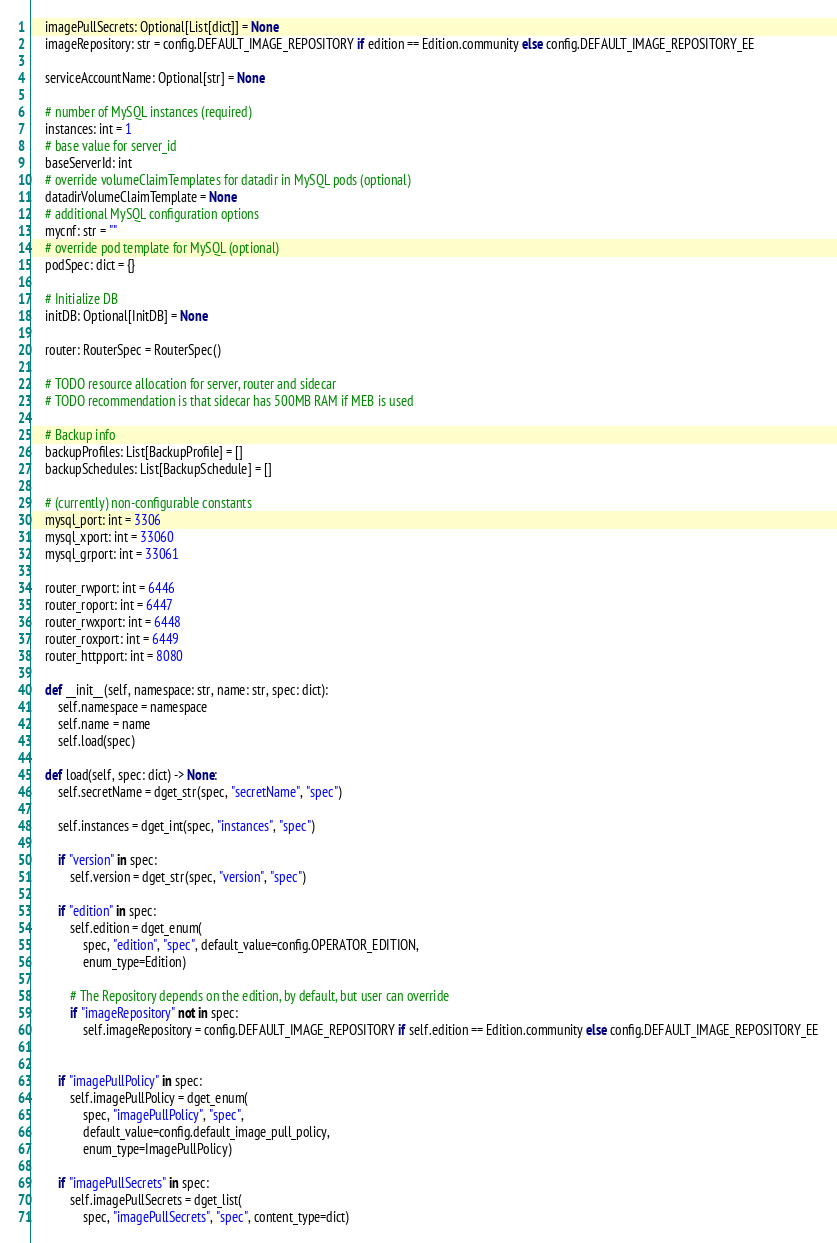<code> <loc_0><loc_0><loc_500><loc_500><_Python_>    imagePullSecrets: Optional[List[dict]] = None
    imageRepository: str = config.DEFAULT_IMAGE_REPOSITORY if edition == Edition.community else config.DEFAULT_IMAGE_REPOSITORY_EE

    serviceAccountName: Optional[str] = None

    # number of MySQL instances (required)
    instances: int = 1
    # base value for server_id
    baseServerId: int
    # override volumeClaimTemplates for datadir in MySQL pods (optional)
    datadirVolumeClaimTemplate = None
    # additional MySQL configuration options
    mycnf: str = ""
    # override pod template for MySQL (optional)
    podSpec: dict = {}

    # Initialize DB
    initDB: Optional[InitDB] = None

    router: RouterSpec = RouterSpec()

    # TODO resource allocation for server, router and sidecar
    # TODO recommendation is that sidecar has 500MB RAM if MEB is used

    # Backup info
    backupProfiles: List[BackupProfile] = []
    backupSchedules: List[BackupSchedule] = []

    # (currently) non-configurable constants
    mysql_port: int = 3306
    mysql_xport: int = 33060
    mysql_grport: int = 33061

    router_rwport: int = 6446
    router_roport: int = 6447
    router_rwxport: int = 6448
    router_roxport: int = 6449
    router_httpport: int = 8080

    def __init__(self, namespace: str, name: str, spec: dict):
        self.namespace = namespace
        self.name = name
        self.load(spec)

    def load(self, spec: dict) -> None:
        self.secretName = dget_str(spec, "secretName", "spec")

        self.instances = dget_int(spec, "instances", "spec")

        if "version" in spec:
            self.version = dget_str(spec, "version", "spec")

        if "edition" in spec:
            self.edition = dget_enum(
                spec, "edition", "spec", default_value=config.OPERATOR_EDITION,
                enum_type=Edition)

            # The Repository depends on the edition, by default, but user can override
            if "imageRepository" not in spec:
                self.imageRepository = config.DEFAULT_IMAGE_REPOSITORY if self.edition == Edition.community else config.DEFAULT_IMAGE_REPOSITORY_EE


        if "imagePullPolicy" in spec:
            self.imagePullPolicy = dget_enum(
                spec, "imagePullPolicy", "spec",
                default_value=config.default_image_pull_policy,
                enum_type=ImagePullPolicy)

        if "imagePullSecrets" in spec:
            self.imagePullSecrets = dget_list(
                spec, "imagePullSecrets", "spec", content_type=dict)
</code> 